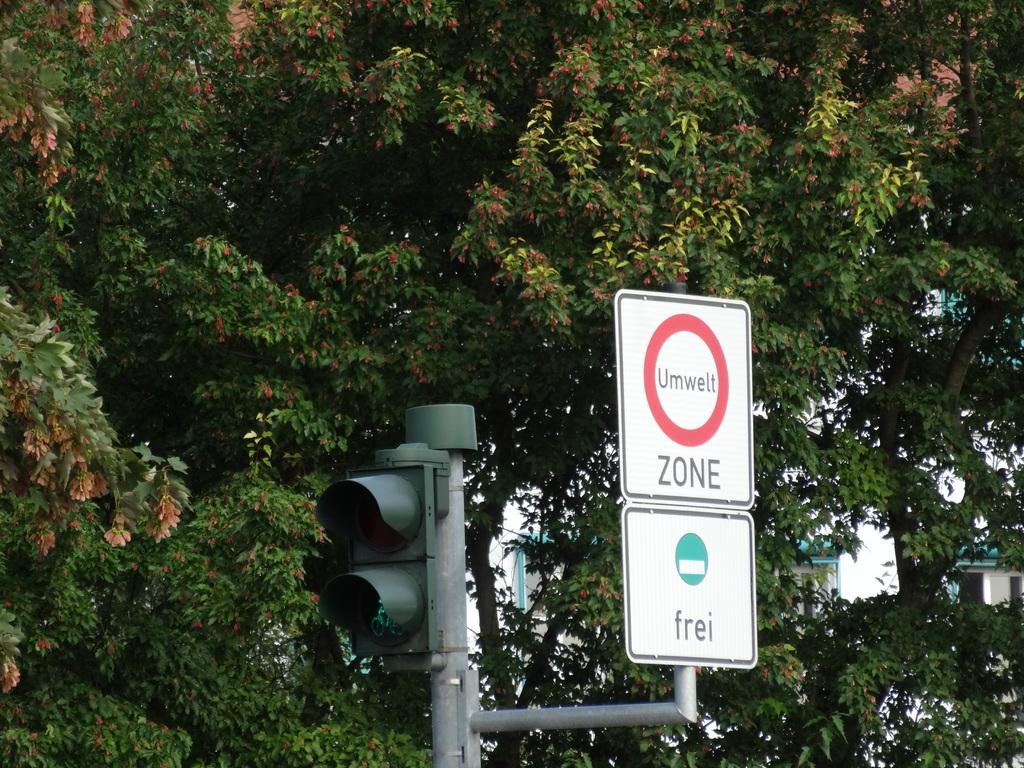What word is in the red ring on the street sign?
Give a very brief answer. Umwelt. 